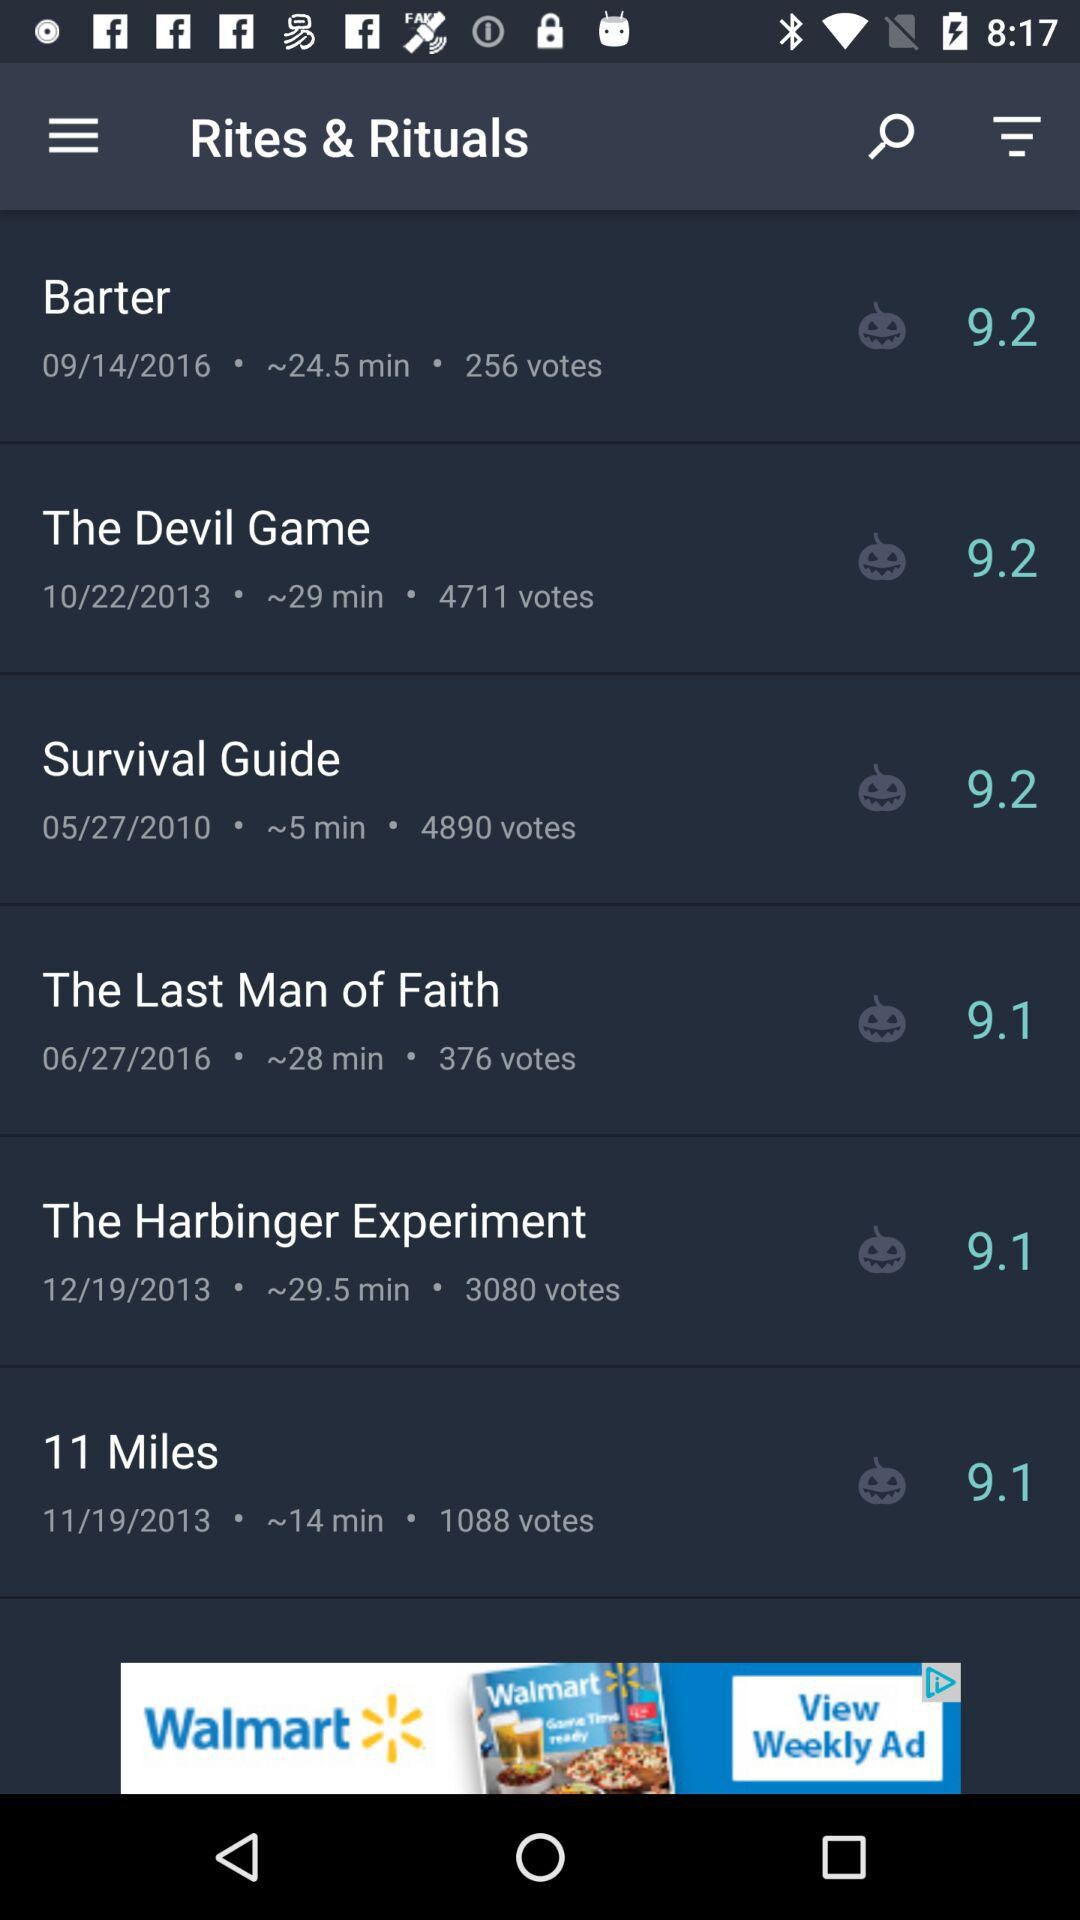What is the date of the "The Last Man of Faith"? The date is 06/27/2016. 